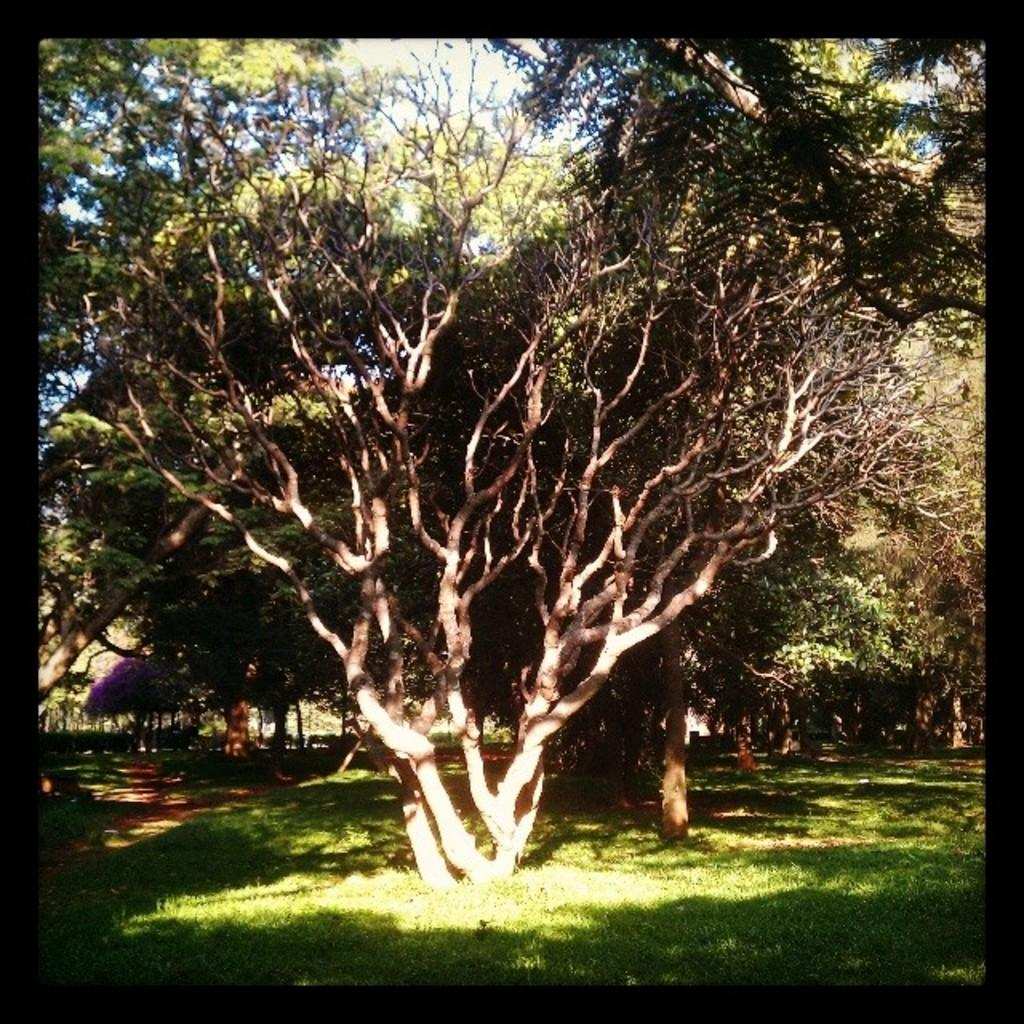What type of vegetation can be seen in the image? There are trees in the image. What is visible at the top of the image? The sky is visible at the top of the image. What type of ground cover is present at the bottom of the image? Grass is present at the bottom of the image. What type of pies are being discussed in the image? There are no pies present in the image, and no discussion about pies is taking place. What system is responsible for the growth of the trees in the image? The image does not provide information about the system responsible for the growth of the trees. 